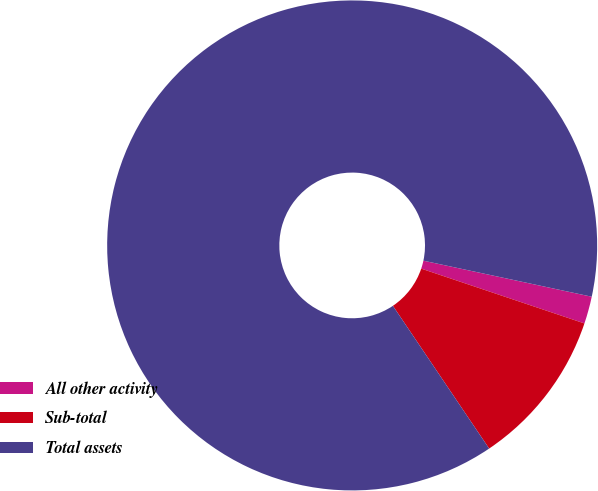Convert chart to OTSL. <chart><loc_0><loc_0><loc_500><loc_500><pie_chart><fcel>All other activity<fcel>Sub-total<fcel>Total assets<nl><fcel>1.8%<fcel>10.4%<fcel>87.79%<nl></chart> 